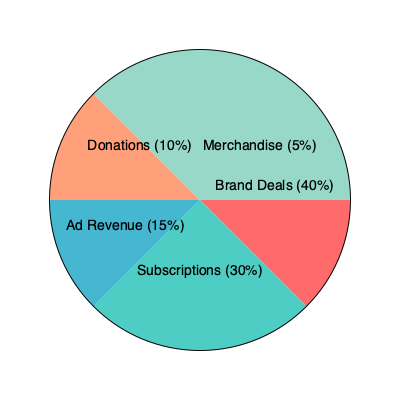As an online content creator, you're analyzing your revenue sources. The pie chart shows the breakdown of your income streams. What percentage of your total revenue comes from the combination of brand deals and subscriptions? To solve this problem, we need to follow these steps:

1. Identify the percentages for brand deals and subscriptions from the pie chart:
   - Brand Deals: 40%
   - Subscriptions: 30%

2. Add these two percentages together:
   $40\% + 30\% = 70\%$

The sum of these two revenue sources represents the combined percentage of total revenue from brand deals and subscriptions.

This calculation shows that brand deals and subscriptions together account for a significant majority of the content creator's income, highlighting the importance of these two revenue streams in the overall business model.
Answer: 70% 